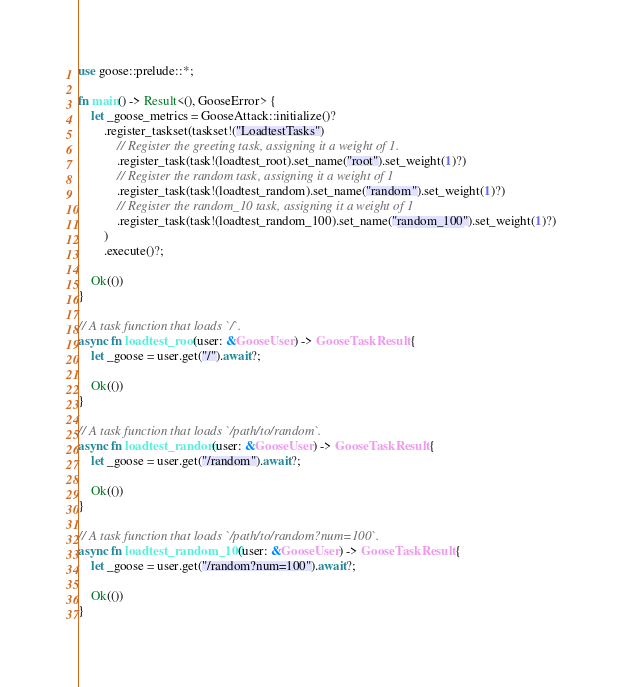Convert code to text. <code><loc_0><loc_0><loc_500><loc_500><_Rust_>use goose::prelude::*;

fn main() -> Result<(), GooseError> {
    let _goose_metrics = GooseAttack::initialize()?
        .register_taskset(taskset!("LoadtestTasks")
            // Register the greeting task, assigning it a weight of 1.
            .register_task(task!(loadtest_root).set_name("root").set_weight(1)?)
            // Register the random task, assigning it a weight of 1
            .register_task(task!(loadtest_random).set_name("random").set_weight(1)?)
            // Register the random_10 task, assigning it a weight of 1
            .register_task(task!(loadtest_random_100).set_name("random_100").set_weight(1)?)
        )
        .execute()?;

    Ok(())
}

// A task function that loads `/`.
async fn loadtest_root(user: &GooseUser) -> GooseTaskResult {
    let _goose = user.get("/").await?;

    Ok(())
}   

// A task function that loads `/path/to/random`.
async fn loadtest_random(user: &GooseUser) -> GooseTaskResult {
    let _goose = user.get("/random").await?;

    Ok(())
} 

// A task function that loads `/path/to/random?num=100`.
async fn loadtest_random_100(user: &GooseUser) -> GooseTaskResult {
    let _goose = user.get("/random?num=100").await?;

    Ok(())
} 
</code> 